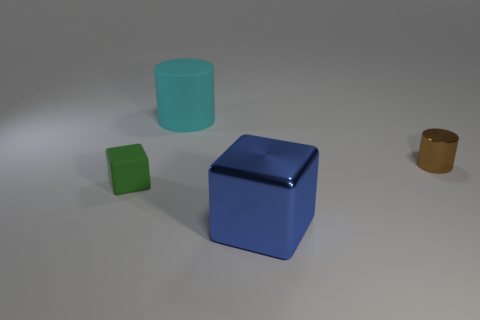Add 4 rubber cubes. How many objects exist? 8 Subtract all purple blocks. Subtract all purple balls. How many blocks are left? 2 Subtract all brown cylinders. How many green cubes are left? 1 Subtract all tiny yellow shiny cylinders. Subtract all rubber cylinders. How many objects are left? 3 Add 3 cylinders. How many cylinders are left? 5 Add 2 large shiny things. How many large shiny things exist? 3 Subtract all brown cylinders. How many cylinders are left? 1 Subtract 0 gray balls. How many objects are left? 4 